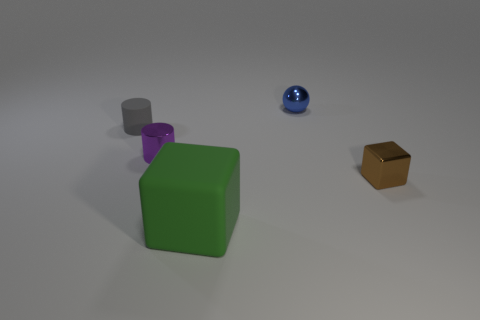There is a metal thing that is behind the object that is on the left side of the tiny shiny cylinder; what is its color?
Offer a terse response. Blue. Is the size of the brown metallic cube the same as the metallic cylinder?
Your response must be concise. Yes. How many balls are small gray matte objects or green things?
Your answer should be very brief. 0. There is a tiny brown shiny block in front of the gray matte cylinder; what number of metal cubes are on the right side of it?
Offer a terse response. 0. Does the large green matte thing have the same shape as the gray rubber thing?
Make the answer very short. No. There is another purple thing that is the same shape as the tiny matte thing; what size is it?
Make the answer very short. Small. There is a small thing behind the rubber object behind the big green rubber cube; what shape is it?
Your answer should be compact. Sphere. The rubber cylinder has what size?
Ensure brevity in your answer.  Small. There is a tiny rubber thing; what shape is it?
Offer a very short reply. Cylinder. There is a large thing; does it have the same shape as the rubber object that is behind the small brown shiny thing?
Ensure brevity in your answer.  No. 